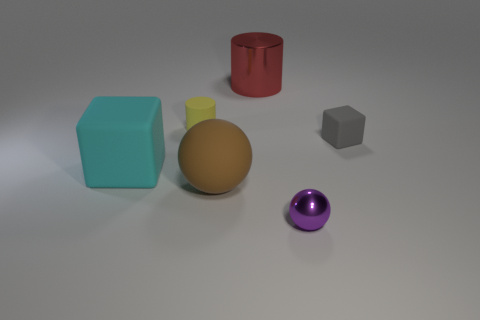What size is the metal object that is the same shape as the tiny yellow matte thing?
Make the answer very short. Large. Are there more brown rubber objects than large green metal things?
Ensure brevity in your answer.  Yes. Is the shape of the big brown object the same as the purple object?
Ensure brevity in your answer.  Yes. What material is the tiny object behind the gray matte block on the right side of the big metallic cylinder?
Make the answer very short. Rubber. Do the red metal thing and the rubber cylinder have the same size?
Offer a terse response. No. There is a shiny thing behind the large matte cube; is there a block to the left of it?
Provide a short and direct response. Yes. The metallic thing that is behind the gray block has what shape?
Give a very brief answer. Cylinder. There is a tiny rubber object that is on the right side of the large thing that is behind the gray thing; how many tiny things are to the left of it?
Keep it short and to the point. 2. There is a matte cylinder; is its size the same as the metallic object that is behind the yellow rubber object?
Give a very brief answer. No. There is a object on the right side of the purple thing on the right side of the large red metallic cylinder; what is its size?
Offer a very short reply. Small. 